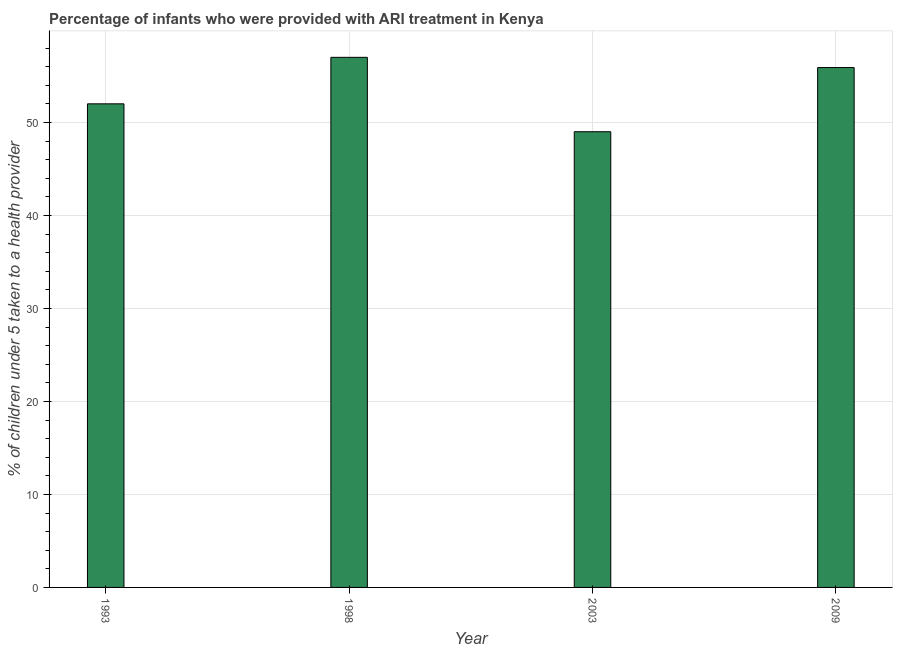Does the graph contain any zero values?
Make the answer very short. No. Does the graph contain grids?
Ensure brevity in your answer.  Yes. What is the title of the graph?
Ensure brevity in your answer.  Percentage of infants who were provided with ARI treatment in Kenya. What is the label or title of the Y-axis?
Provide a short and direct response. % of children under 5 taken to a health provider. What is the percentage of children who were provided with ari treatment in 2009?
Provide a short and direct response. 55.9. Across all years, what is the maximum percentage of children who were provided with ari treatment?
Offer a terse response. 57. Across all years, what is the minimum percentage of children who were provided with ari treatment?
Provide a short and direct response. 49. In which year was the percentage of children who were provided with ari treatment minimum?
Provide a succinct answer. 2003. What is the sum of the percentage of children who were provided with ari treatment?
Provide a succinct answer. 213.9. What is the difference between the percentage of children who were provided with ari treatment in 1998 and 2009?
Offer a terse response. 1.1. What is the average percentage of children who were provided with ari treatment per year?
Provide a short and direct response. 53.48. What is the median percentage of children who were provided with ari treatment?
Provide a succinct answer. 53.95. In how many years, is the percentage of children who were provided with ari treatment greater than 54 %?
Give a very brief answer. 2. Do a majority of the years between 1998 and 2003 (inclusive) have percentage of children who were provided with ari treatment greater than 46 %?
Keep it short and to the point. Yes. Is the sum of the percentage of children who were provided with ari treatment in 1993 and 2009 greater than the maximum percentage of children who were provided with ari treatment across all years?
Give a very brief answer. Yes. In how many years, is the percentage of children who were provided with ari treatment greater than the average percentage of children who were provided with ari treatment taken over all years?
Ensure brevity in your answer.  2. Are all the bars in the graph horizontal?
Offer a very short reply. No. What is the % of children under 5 taken to a health provider in 2003?
Ensure brevity in your answer.  49. What is the % of children under 5 taken to a health provider in 2009?
Provide a short and direct response. 55.9. What is the difference between the % of children under 5 taken to a health provider in 1998 and 2003?
Offer a very short reply. 8. What is the difference between the % of children under 5 taken to a health provider in 1998 and 2009?
Your answer should be compact. 1.1. What is the difference between the % of children under 5 taken to a health provider in 2003 and 2009?
Ensure brevity in your answer.  -6.9. What is the ratio of the % of children under 5 taken to a health provider in 1993 to that in 1998?
Provide a short and direct response. 0.91. What is the ratio of the % of children under 5 taken to a health provider in 1993 to that in 2003?
Make the answer very short. 1.06. What is the ratio of the % of children under 5 taken to a health provider in 1993 to that in 2009?
Provide a short and direct response. 0.93. What is the ratio of the % of children under 5 taken to a health provider in 1998 to that in 2003?
Provide a succinct answer. 1.16. What is the ratio of the % of children under 5 taken to a health provider in 2003 to that in 2009?
Offer a terse response. 0.88. 